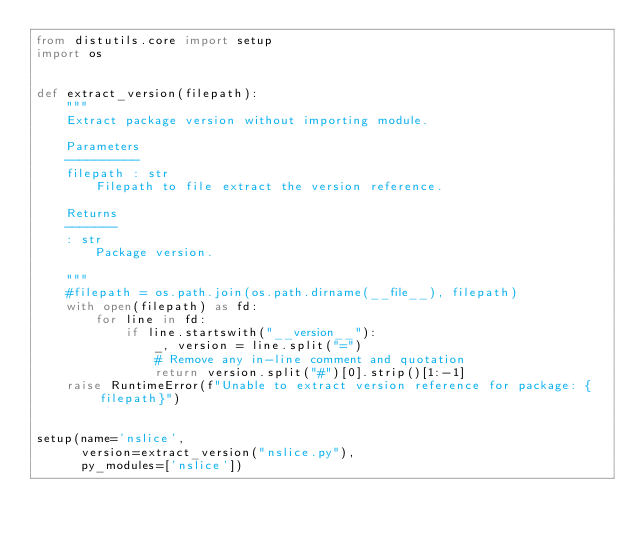<code> <loc_0><loc_0><loc_500><loc_500><_Python_>from distutils.core import setup
import os


def extract_version(filepath):
    """
    Extract package version without importing module.

    Parameters
    ----------
    filepath : str
        Filepath to file extract the version reference.

    Returns
    -------
    : str
        Package version.

    """
    #filepath = os.path.join(os.path.dirname(__file__), filepath)
    with open(filepath) as fd:
        for line in fd:
            if line.startswith("__version__"):
                _, version = line.split("=")
                # Remove any in-line comment and quotation
                return version.split("#")[0].strip()[1:-1]
    raise RuntimeError(f"Unable to extract version reference for package: {filepath}")


setup(name='nslice',
      version=extract_version("nslice.py"),
      py_modules=['nslice'])</code> 